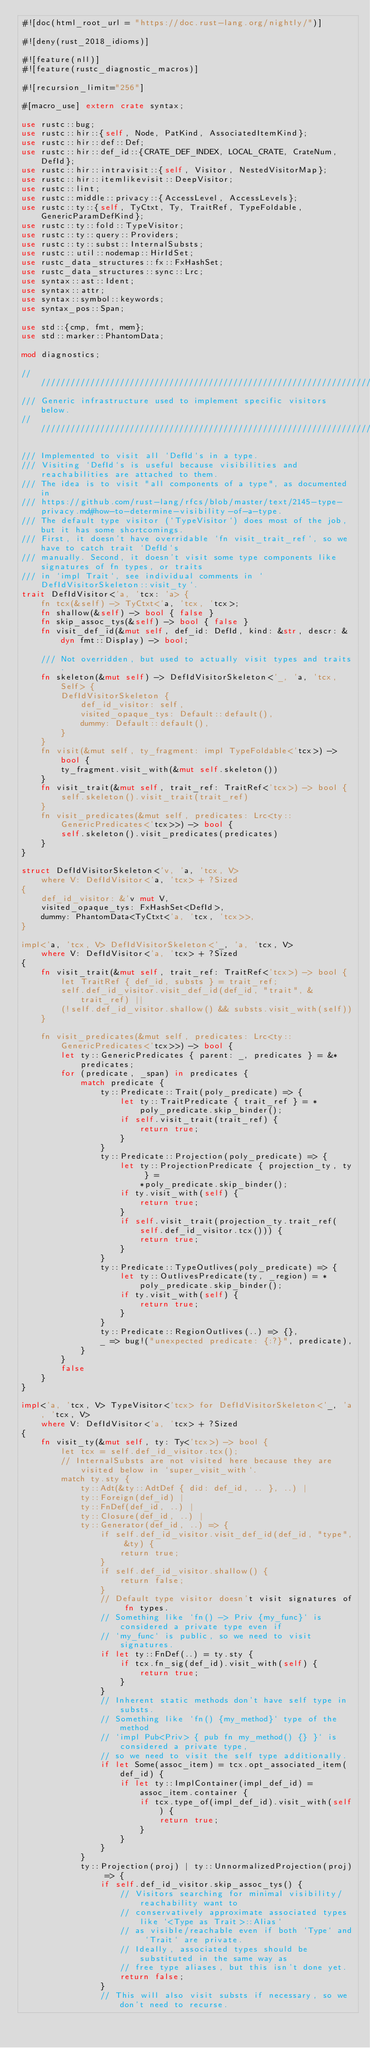<code> <loc_0><loc_0><loc_500><loc_500><_Rust_>#![doc(html_root_url = "https://doc.rust-lang.org/nightly/")]

#![deny(rust_2018_idioms)]

#![feature(nll)]
#![feature(rustc_diagnostic_macros)]

#![recursion_limit="256"]

#[macro_use] extern crate syntax;

use rustc::bug;
use rustc::hir::{self, Node, PatKind, AssociatedItemKind};
use rustc::hir::def::Def;
use rustc::hir::def_id::{CRATE_DEF_INDEX, LOCAL_CRATE, CrateNum, DefId};
use rustc::hir::intravisit::{self, Visitor, NestedVisitorMap};
use rustc::hir::itemlikevisit::DeepVisitor;
use rustc::lint;
use rustc::middle::privacy::{AccessLevel, AccessLevels};
use rustc::ty::{self, TyCtxt, Ty, TraitRef, TypeFoldable, GenericParamDefKind};
use rustc::ty::fold::TypeVisitor;
use rustc::ty::query::Providers;
use rustc::ty::subst::InternalSubsts;
use rustc::util::nodemap::HirIdSet;
use rustc_data_structures::fx::FxHashSet;
use rustc_data_structures::sync::Lrc;
use syntax::ast::Ident;
use syntax::attr;
use syntax::symbol::keywords;
use syntax_pos::Span;

use std::{cmp, fmt, mem};
use std::marker::PhantomData;

mod diagnostics;

////////////////////////////////////////////////////////////////////////////////
/// Generic infrastructure used to implement specific visitors below.
////////////////////////////////////////////////////////////////////////////////

/// Implemented to visit all `DefId`s in a type.
/// Visiting `DefId`s is useful because visibilities and reachabilities are attached to them.
/// The idea is to visit "all components of a type", as documented in
/// https://github.com/rust-lang/rfcs/blob/master/text/2145-type-privacy.md#how-to-determine-visibility-of-a-type.
/// The default type visitor (`TypeVisitor`) does most of the job, but it has some shortcomings.
/// First, it doesn't have overridable `fn visit_trait_ref`, so we have to catch trait `DefId`s
/// manually. Second, it doesn't visit some type components like signatures of fn types, or traits
/// in `impl Trait`, see individual comments in `DefIdVisitorSkeleton::visit_ty`.
trait DefIdVisitor<'a, 'tcx: 'a> {
    fn tcx(&self) -> TyCtxt<'a, 'tcx, 'tcx>;
    fn shallow(&self) -> bool { false }
    fn skip_assoc_tys(&self) -> bool { false }
    fn visit_def_id(&mut self, def_id: DefId, kind: &str, descr: &dyn fmt::Display) -> bool;

    /// Not overridden, but used to actually visit types and traits.
    fn skeleton(&mut self) -> DefIdVisitorSkeleton<'_, 'a, 'tcx, Self> {
        DefIdVisitorSkeleton {
            def_id_visitor: self,
            visited_opaque_tys: Default::default(),
            dummy: Default::default(),
        }
    }
    fn visit(&mut self, ty_fragment: impl TypeFoldable<'tcx>) -> bool {
        ty_fragment.visit_with(&mut self.skeleton())
    }
    fn visit_trait(&mut self, trait_ref: TraitRef<'tcx>) -> bool {
        self.skeleton().visit_trait(trait_ref)
    }
    fn visit_predicates(&mut self, predicates: Lrc<ty::GenericPredicates<'tcx>>) -> bool {
        self.skeleton().visit_predicates(predicates)
    }
}

struct DefIdVisitorSkeleton<'v, 'a, 'tcx, V>
    where V: DefIdVisitor<'a, 'tcx> + ?Sized
{
    def_id_visitor: &'v mut V,
    visited_opaque_tys: FxHashSet<DefId>,
    dummy: PhantomData<TyCtxt<'a, 'tcx, 'tcx>>,
}

impl<'a, 'tcx, V> DefIdVisitorSkeleton<'_, 'a, 'tcx, V>
    where V: DefIdVisitor<'a, 'tcx> + ?Sized
{
    fn visit_trait(&mut self, trait_ref: TraitRef<'tcx>) -> bool {
        let TraitRef { def_id, substs } = trait_ref;
        self.def_id_visitor.visit_def_id(def_id, "trait", &trait_ref) ||
        (!self.def_id_visitor.shallow() && substs.visit_with(self))
    }

    fn visit_predicates(&mut self, predicates: Lrc<ty::GenericPredicates<'tcx>>) -> bool {
        let ty::GenericPredicates { parent: _, predicates } = &*predicates;
        for (predicate, _span) in predicates {
            match predicate {
                ty::Predicate::Trait(poly_predicate) => {
                    let ty::TraitPredicate { trait_ref } = *poly_predicate.skip_binder();
                    if self.visit_trait(trait_ref) {
                        return true;
                    }
                }
                ty::Predicate::Projection(poly_predicate) => {
                    let ty::ProjectionPredicate { projection_ty, ty } =
                        *poly_predicate.skip_binder();
                    if ty.visit_with(self) {
                        return true;
                    }
                    if self.visit_trait(projection_ty.trait_ref(self.def_id_visitor.tcx())) {
                        return true;
                    }
                }
                ty::Predicate::TypeOutlives(poly_predicate) => {
                    let ty::OutlivesPredicate(ty, _region) = *poly_predicate.skip_binder();
                    if ty.visit_with(self) {
                        return true;
                    }
                }
                ty::Predicate::RegionOutlives(..) => {},
                _ => bug!("unexpected predicate: {:?}", predicate),
            }
        }
        false
    }
}

impl<'a, 'tcx, V> TypeVisitor<'tcx> for DefIdVisitorSkeleton<'_, 'a, 'tcx, V>
    where V: DefIdVisitor<'a, 'tcx> + ?Sized
{
    fn visit_ty(&mut self, ty: Ty<'tcx>) -> bool {
        let tcx = self.def_id_visitor.tcx();
        // InternalSubsts are not visited here because they are visited below in `super_visit_with`.
        match ty.sty {
            ty::Adt(&ty::AdtDef { did: def_id, .. }, ..) |
            ty::Foreign(def_id) |
            ty::FnDef(def_id, ..) |
            ty::Closure(def_id, ..) |
            ty::Generator(def_id, ..) => {
                if self.def_id_visitor.visit_def_id(def_id, "type", &ty) {
                    return true;
                }
                if self.def_id_visitor.shallow() {
                    return false;
                }
                // Default type visitor doesn't visit signatures of fn types.
                // Something like `fn() -> Priv {my_func}` is considered a private type even if
                // `my_func` is public, so we need to visit signatures.
                if let ty::FnDef(..) = ty.sty {
                    if tcx.fn_sig(def_id).visit_with(self) {
                        return true;
                    }
                }
                // Inherent static methods don't have self type in substs.
                // Something like `fn() {my_method}` type of the method
                // `impl Pub<Priv> { pub fn my_method() {} }` is considered a private type,
                // so we need to visit the self type additionally.
                if let Some(assoc_item) = tcx.opt_associated_item(def_id) {
                    if let ty::ImplContainer(impl_def_id) = assoc_item.container {
                        if tcx.type_of(impl_def_id).visit_with(self) {
                            return true;
                        }
                    }
                }
            }
            ty::Projection(proj) | ty::UnnormalizedProjection(proj) => {
                if self.def_id_visitor.skip_assoc_tys() {
                    // Visitors searching for minimal visibility/reachability want to
                    // conservatively approximate associated types like `<Type as Trait>::Alias`
                    // as visible/reachable even if both `Type` and `Trait` are private.
                    // Ideally, associated types should be substituted in the same way as
                    // free type aliases, but this isn't done yet.
                    return false;
                }
                // This will also visit substs if necessary, so we don't need to recurse.</code> 